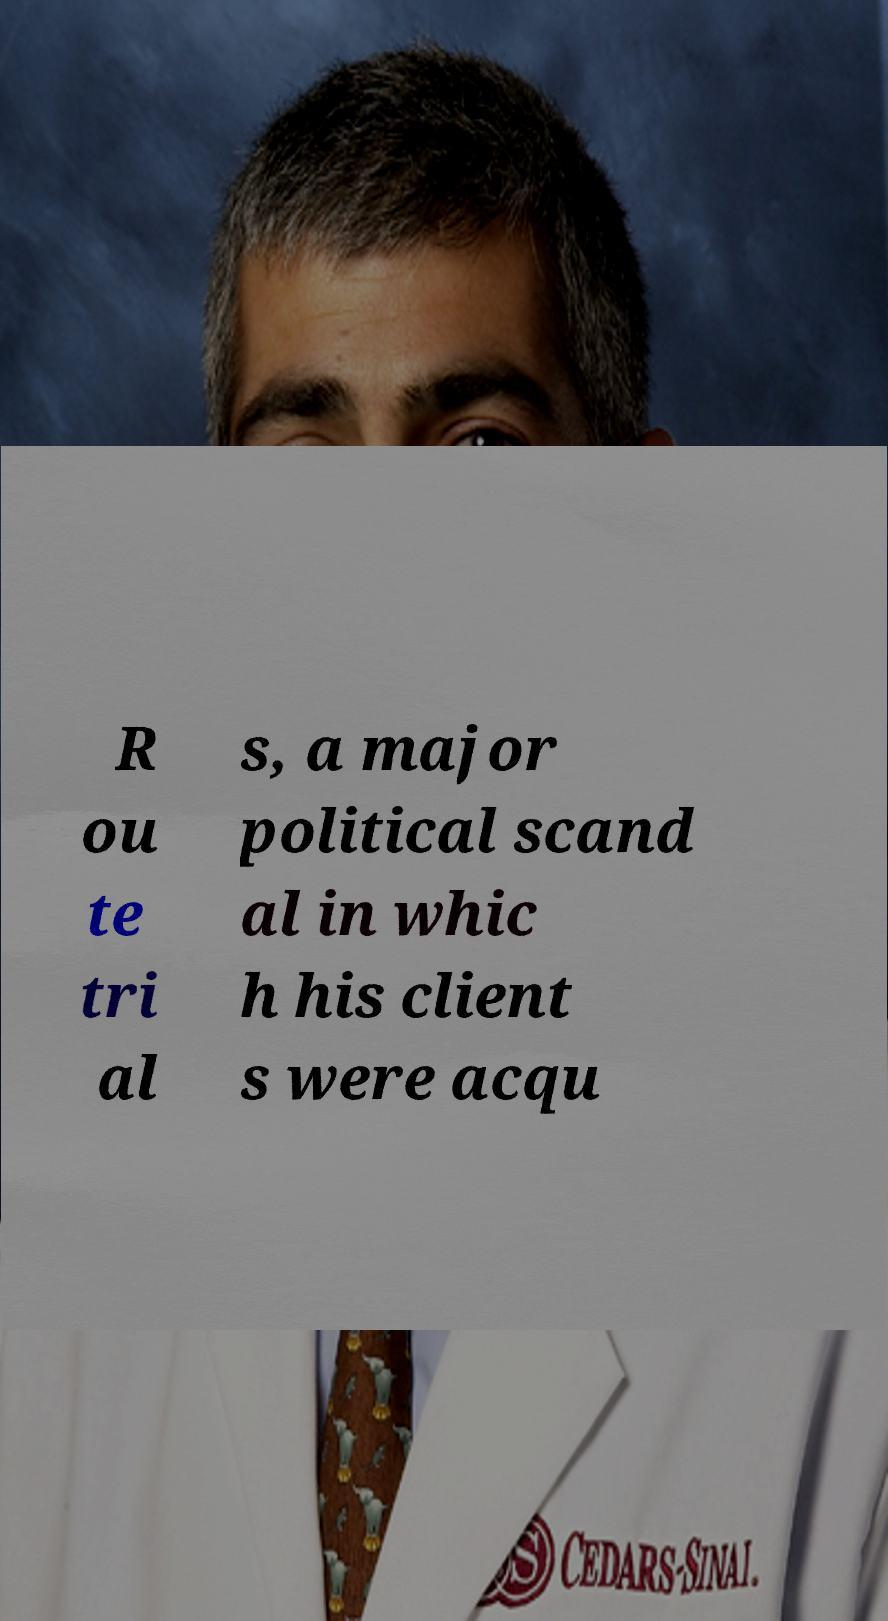For documentation purposes, I need the text within this image transcribed. Could you provide that? R ou te tri al s, a major political scand al in whic h his client s were acqu 